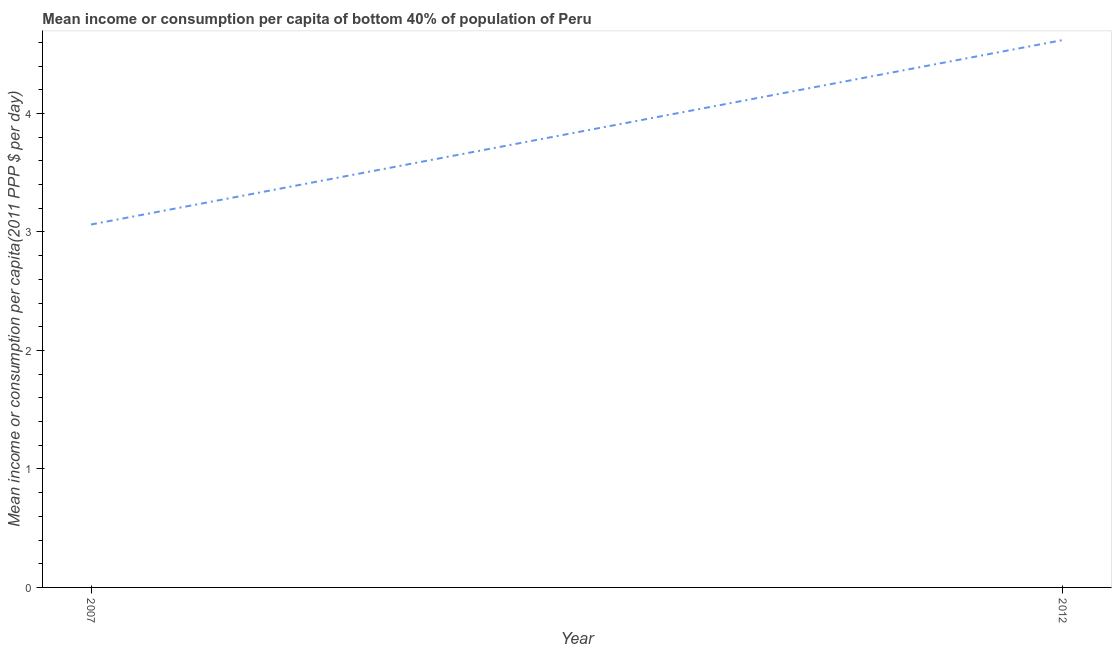What is the mean income or consumption in 2012?
Give a very brief answer. 4.62. Across all years, what is the maximum mean income or consumption?
Provide a succinct answer. 4.62. Across all years, what is the minimum mean income or consumption?
Your answer should be very brief. 3.06. What is the sum of the mean income or consumption?
Keep it short and to the point. 7.68. What is the difference between the mean income or consumption in 2007 and 2012?
Provide a short and direct response. -1.56. What is the average mean income or consumption per year?
Give a very brief answer. 3.84. What is the median mean income or consumption?
Make the answer very short. 3.84. What is the ratio of the mean income or consumption in 2007 to that in 2012?
Provide a succinct answer. 0.66. Is the mean income or consumption in 2007 less than that in 2012?
Keep it short and to the point. Yes. In how many years, is the mean income or consumption greater than the average mean income or consumption taken over all years?
Provide a succinct answer. 1. Does the mean income or consumption monotonically increase over the years?
Your answer should be very brief. Yes. How many lines are there?
Provide a succinct answer. 1. Are the values on the major ticks of Y-axis written in scientific E-notation?
Your answer should be compact. No. Does the graph contain grids?
Ensure brevity in your answer.  No. What is the title of the graph?
Give a very brief answer. Mean income or consumption per capita of bottom 40% of population of Peru. What is the label or title of the X-axis?
Your answer should be compact. Year. What is the label or title of the Y-axis?
Offer a very short reply. Mean income or consumption per capita(2011 PPP $ per day). What is the Mean income or consumption per capita(2011 PPP $ per day) of 2007?
Offer a terse response. 3.06. What is the Mean income or consumption per capita(2011 PPP $ per day) in 2012?
Offer a terse response. 4.62. What is the difference between the Mean income or consumption per capita(2011 PPP $ per day) in 2007 and 2012?
Offer a terse response. -1.56. What is the ratio of the Mean income or consumption per capita(2011 PPP $ per day) in 2007 to that in 2012?
Your answer should be compact. 0.66. 